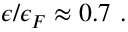Convert formula to latex. <formula><loc_0><loc_0><loc_500><loc_500>\epsilon / \epsilon _ { F } \approx 0 . 7 .</formula> 